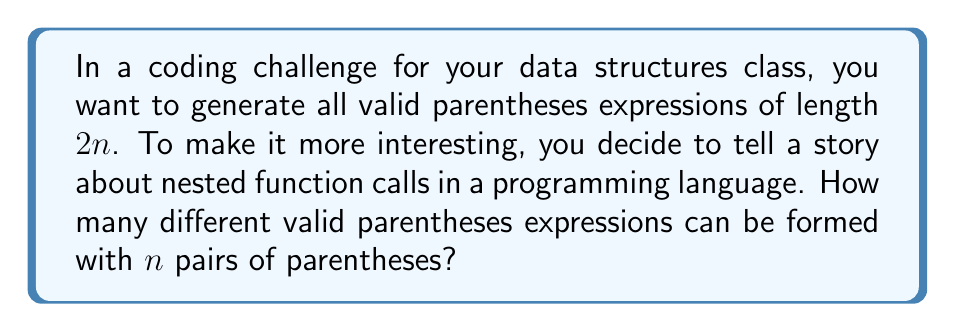Teach me how to tackle this problem. Let's approach this step-by-step:

1) First, we recognize that this problem is equivalent to finding the $n$-th Catalan number, $C_n$.

2) The Catalan numbers have a closed-form expression:

   $$C_n = \frac{1}{n+1}\binom{2n}{n}$$

3) To understand why this works, let's consider the structure of valid parentheses:
   - Every valid expression starts with an opening parenthesis and ends with a closing parenthesis.
   - Between these, we can have any valid expression, followed by another valid expression.

4) This recursive structure is exactly what the Catalan numbers describe.

5) Now, let's break down the formula:
   - $\binom{2n}{n}$ represents the total number of ways to choose $n$ positions out of $2n$ for opening parentheses (the rest will be closing parentheses).
   - However, not all of these are valid. The $\frac{1}{n+1}$ factor corrects for this.

6) To compute this for a specific $n$, we can use:

   $$C_n = \frac{(2n)!}{(n+1)!n!}$$

7) For example, if $n = 3$:

   $$C_3 = \frac{6!}{4!3!} = \frac{720}{144} = 5$$

8) Indeed, for $n=3$, the valid expressions are:
   ((())), ()(()), ()()(), (())(), (()())

This formula gives us a direct way to compute the number of valid parentheses expressions for any $n$.
Answer: $\frac{1}{n+1}\binom{2n}{n}$ or $\frac{(2n)!}{(n+1)!n!}$ 